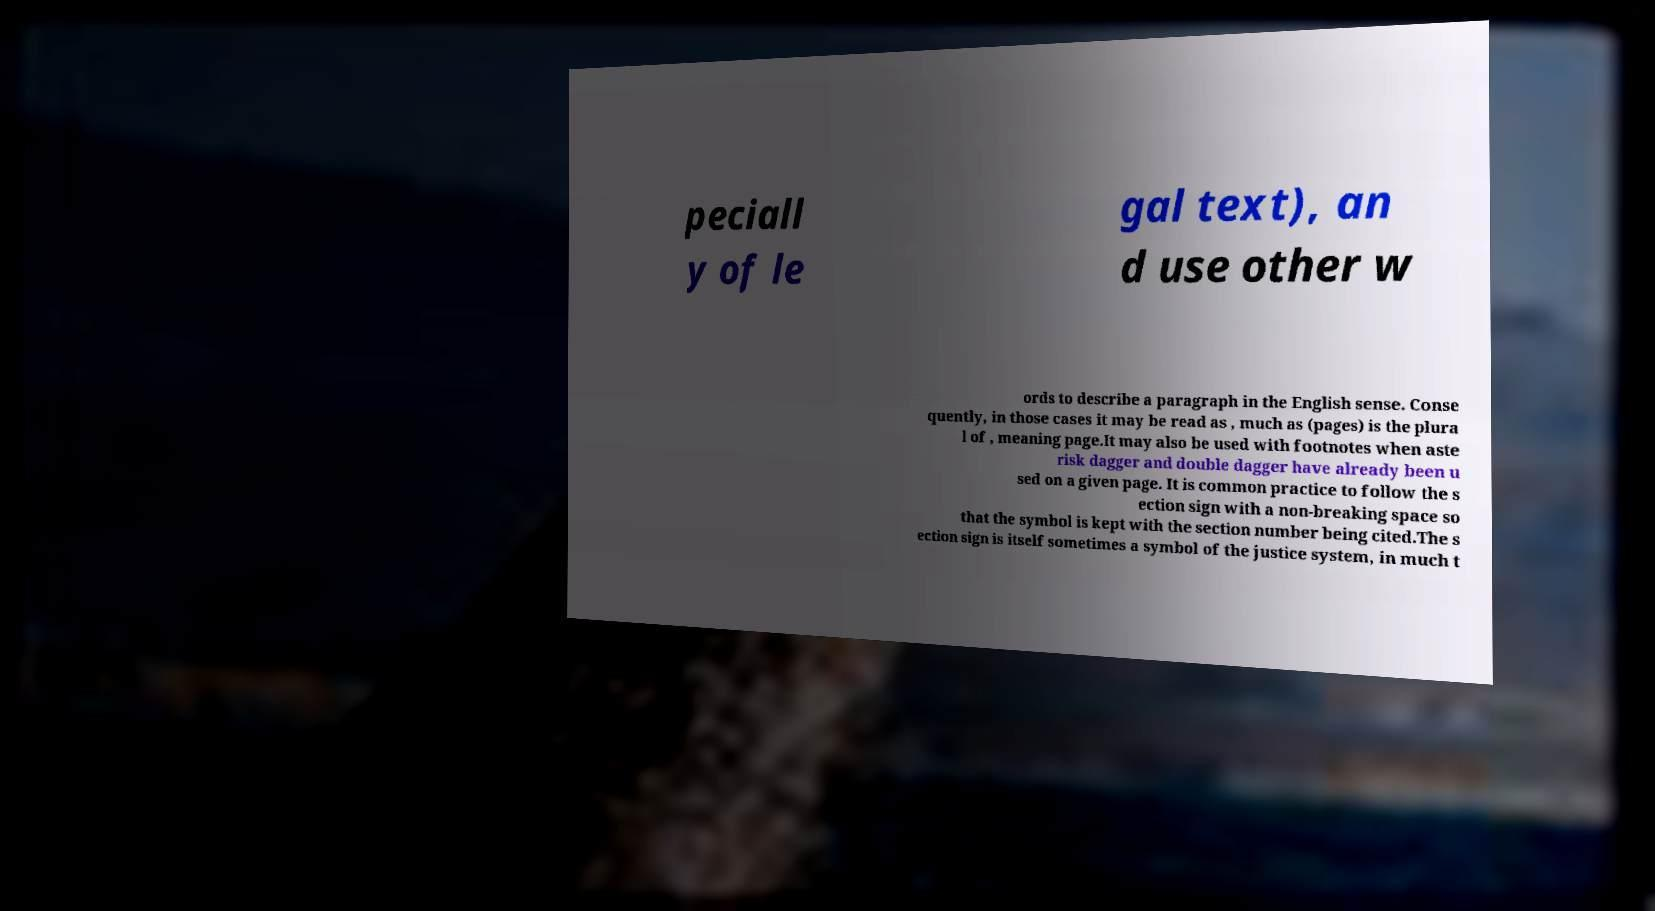Could you extract and type out the text from this image? peciall y of le gal text), an d use other w ords to describe a paragraph in the English sense. Conse quently, in those cases it may be read as , much as (pages) is the plura l of , meaning page.It may also be used with footnotes when aste risk dagger and double dagger have already been u sed on a given page. It is common practice to follow the s ection sign with a non-breaking space so that the symbol is kept with the section number being cited.The s ection sign is itself sometimes a symbol of the justice system, in much t 